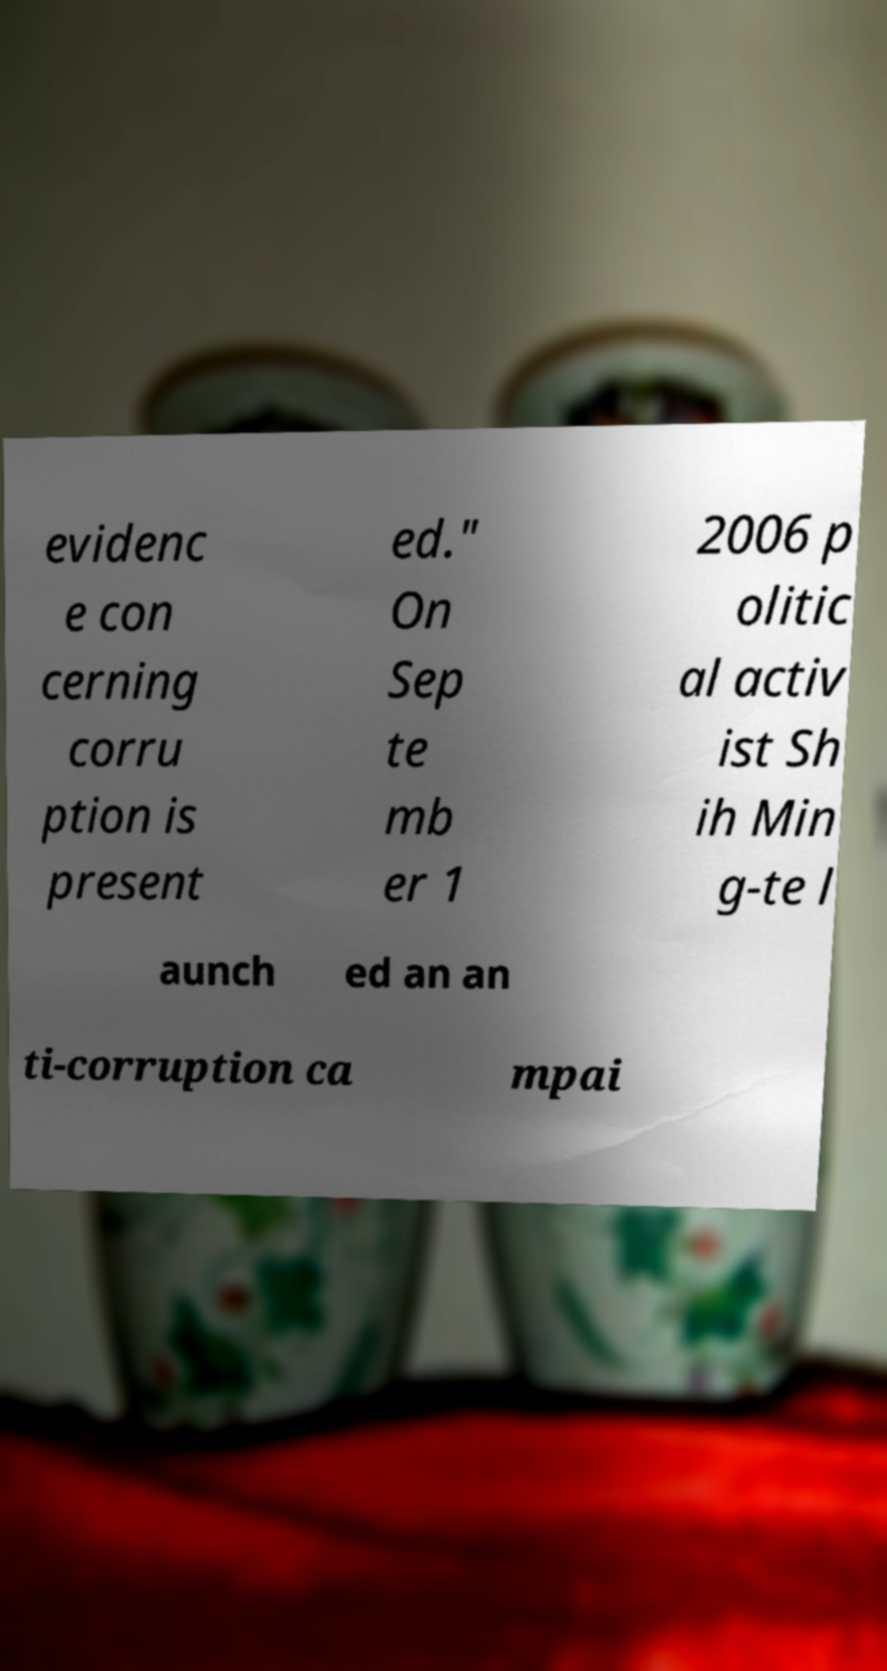Can you accurately transcribe the text from the provided image for me? evidenc e con cerning corru ption is present ed." On Sep te mb er 1 2006 p olitic al activ ist Sh ih Min g-te l aunch ed an an ti-corruption ca mpai 